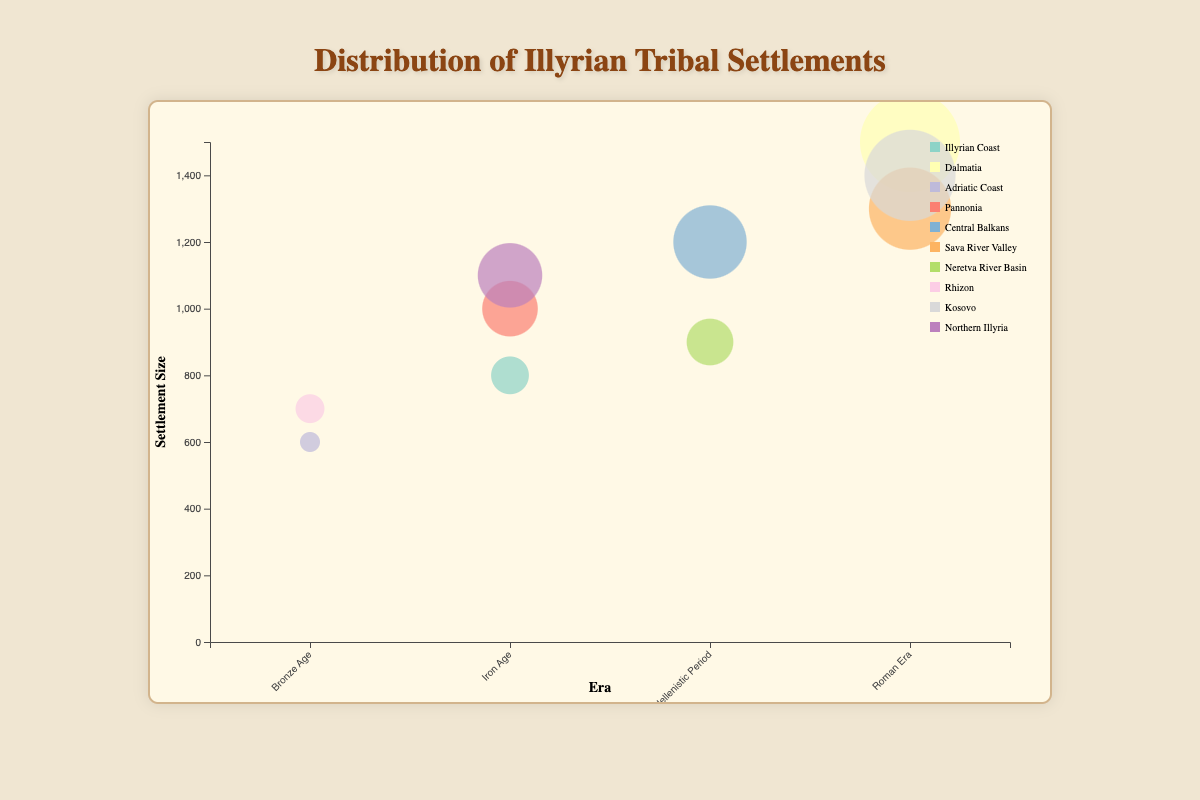What's the title of the figure? The title is centered at the top of the figure and indicates the subject of the visualization.
Answer: Distribution of Illyrian Tribal Settlements Which era has the largest settlement size? The eras are marked on the x-axis, and the settlement sizes are indicated by the size of the bubbles. The largest bubble along the x-axis is in the Roman Era.
Answer: Roman Era What is the size of the largest settlement and which tribe does it belong to? The largest bubble on the chart represents the settlement size of 1500, and the tooltip information from hovering over the bubble shows that it belongs to the Dalmatae tribe.
Answer: 1500, Dalmatae How many tribes are presented in the Hellenistic Period? By identifying the bubbles along the x-axis under the Hellenistic Period and checking the tooltips, we find there are two tribes in this era.
Answer: 2 Which location has the most varied representation across different eras? Different colors represent different locations, and the tooltip information can identify the number of unique eras associated with each location's bubbles. The Central Balkans and Neretva River Basin have multiple eras represented.
Answer: Central Balkans and Neretva River Basin Which tribe has the smallest settlement in the Bronze Age and what is the size? By inspecting the bubbles in the Bronze Age and utilizing the tooltip information, the smallest settlement size is 600, belonging to the Liburni tribe.
Answer: Liburni, 600 Are there any tribes from the Iron Age with settlements larger than 1000? Analyzing the bubbles under the Iron Age and checking sizes with the tooltip information shows that the Iapydes have a settlement size of 1100.
Answer: Yes What's the average settlement size for the Hellenistic Period? The Hellenistic Period has two settlements with sizes of 1200 and 900. The average is calculated by (1200 + 900) / 2 = 1050.
Answer: 1050 How does the settlement size of the Pannonians compare to that of the Iapydes? Comparing the sizes from the tooltips: Pannonians (1000) and Iapydes (1100). The Iapydes have a larger settlement size by 100 units.
Answer: Iapydes' size is 100 units larger How many different geographic locations are represented in the bubble chart? Each location is represented by a unique color. Counting the different colors and checking the legend reveals there are nine distinct locations.
Answer: 9 